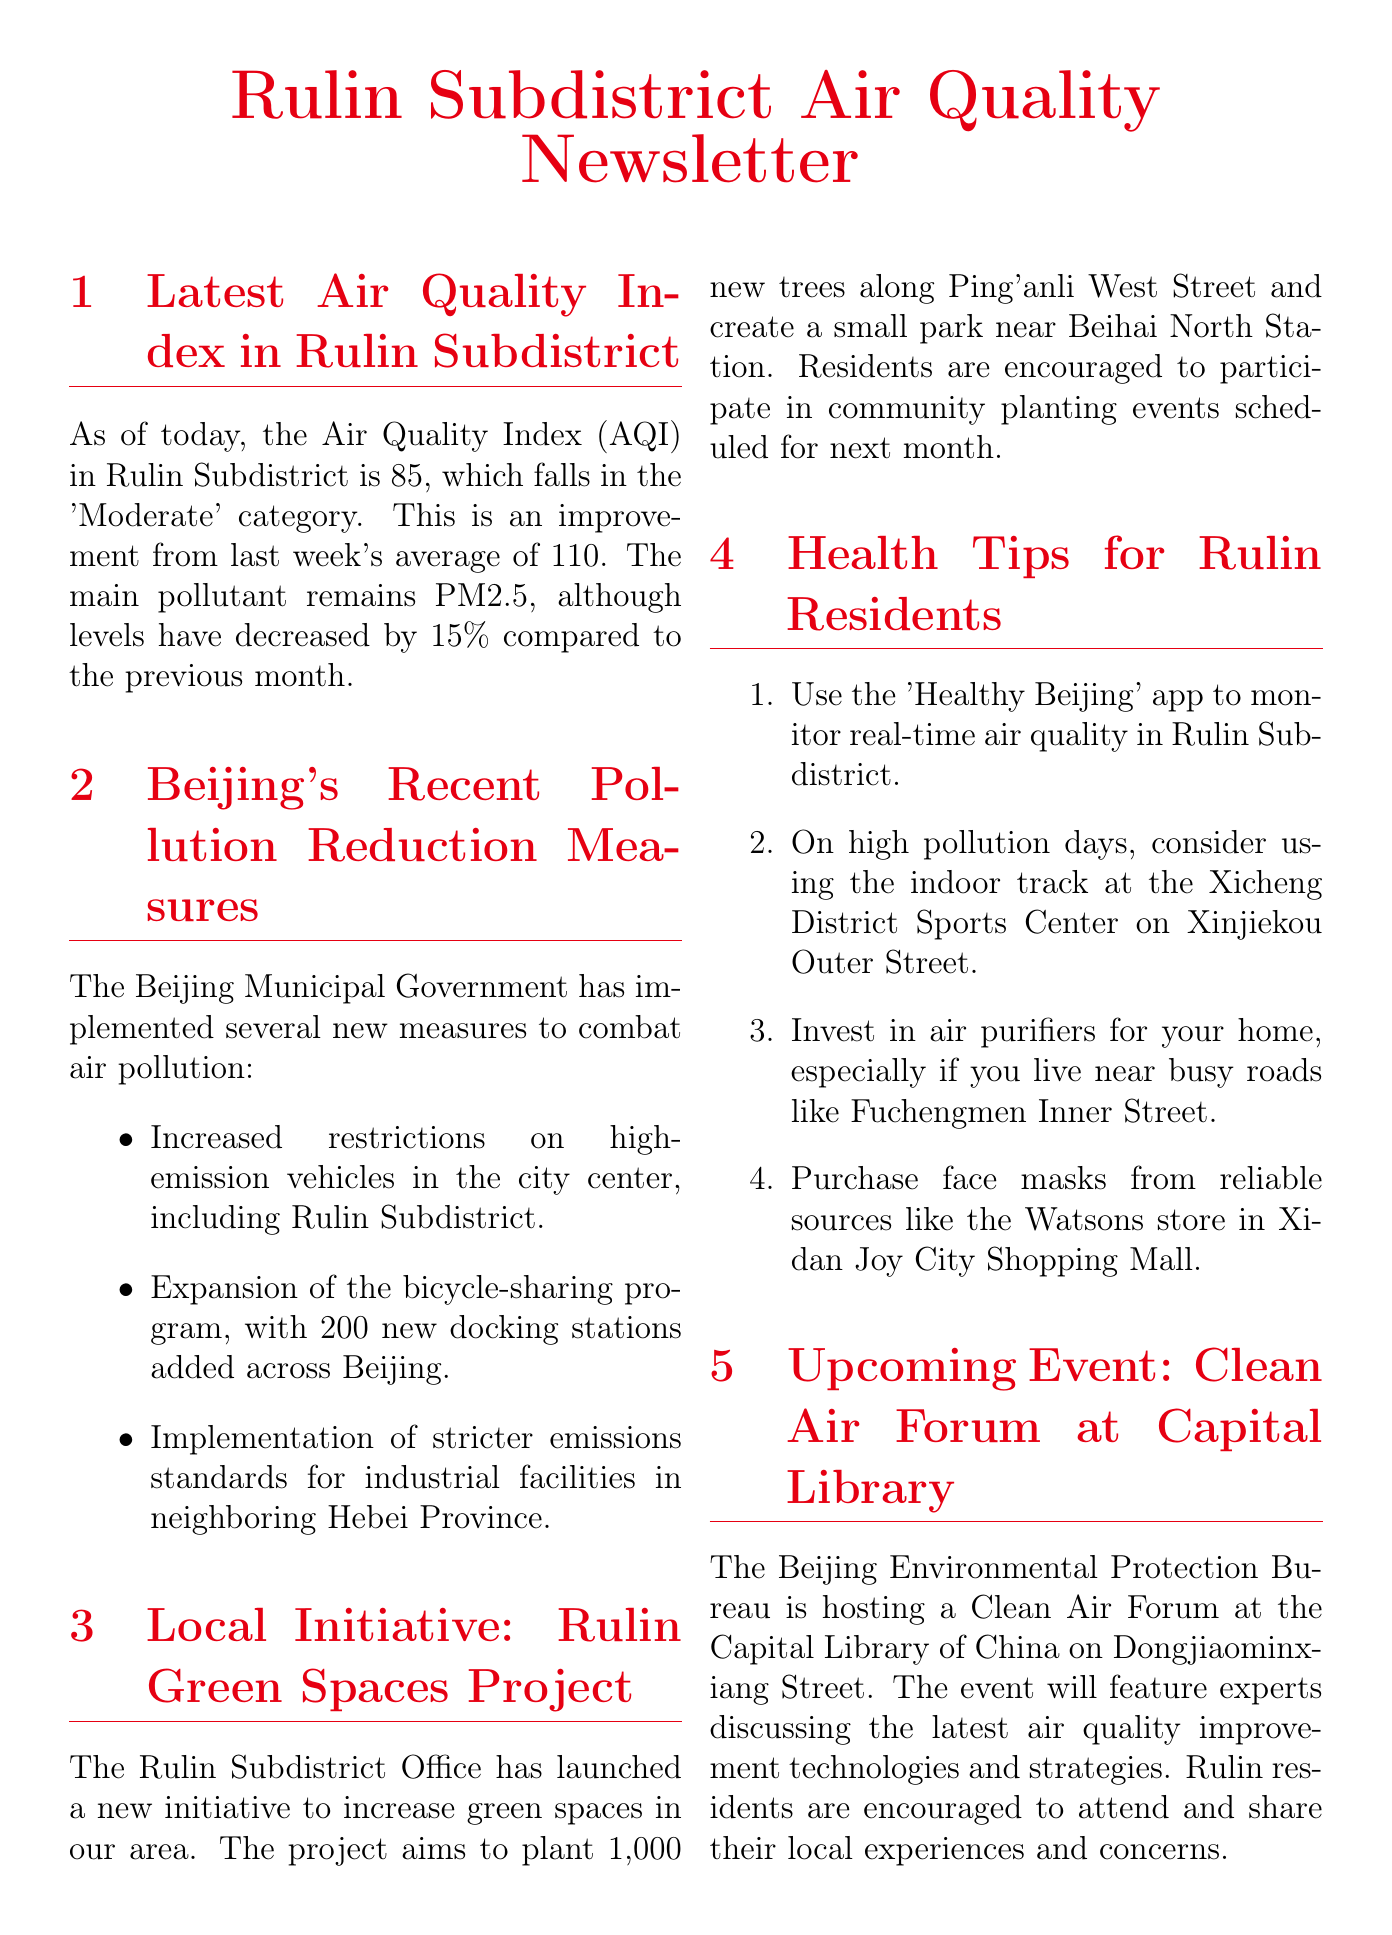What is the AQI in Rulin Subdistrict today? The document states that the AQI in Rulin Subdistrict is 85 as of today.
Answer: 85 What was last week's average AQI? The document provides information that last week's average AQI was 110.
Answer: 110 What is the main pollutant mentioned in the newsletter? The newsletter indicates that the main pollutant remains PM2.5.
Answer: PM2.5 How many new trees are planned to be planted in the Rulin Green Spaces Project? According to the document, the project aims to plant 1,000 new trees.
Answer: 1,000 Where will the Clean Air Forum be held? The document mentions that the forum will be held at the Capital Library of China.
Answer: Capital Library of China What app can residents use to monitor real-time air quality? The document suggests using the 'Healthy Beijing' app.
Answer: Healthy Beijing What are the new restrictions related to high-emission vehicles? The document states that there are increased restrictions on high-emission vehicles in the city center.
Answer: Increased restrictions What is one health tip for high pollution days? The newsletter recommends considering using the indoor track at the Xicheng District Sports Center.
Answer: Indoor track at Xicheng Sports Center How many new docking stations have been added to the bicycle-sharing program? The document mentions that 200 new docking stations have been added across Beijing.
Answer: 200 